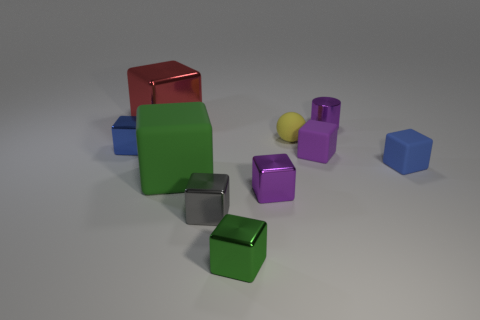What number of other things are the same material as the gray object?
Make the answer very short. 5. What number of red things are large objects or shiny things?
Ensure brevity in your answer.  1. There is a small purple thing that is behind the ball; does it have the same shape as the blue thing that is right of the large green matte block?
Keep it short and to the point. No. Does the rubber sphere have the same color as the shiny thing that is left of the red thing?
Keep it short and to the point. No. There is a small metal object that is to the right of the purple metal cube; is it the same color as the matte sphere?
Give a very brief answer. No. What number of things are either purple metal objects or green rubber objects that are on the left side of the tiny cylinder?
Keep it short and to the point. 3. There is a tiny block that is both to the left of the blue rubber thing and right of the yellow thing; what is its material?
Your response must be concise. Rubber. What is the blue object that is left of the blue matte thing made of?
Give a very brief answer. Metal. What is the color of the small cylinder that is the same material as the large red thing?
Offer a very short reply. Purple. Do the yellow thing and the tiny purple object that is behind the tiny blue metallic cube have the same shape?
Your response must be concise. No. 